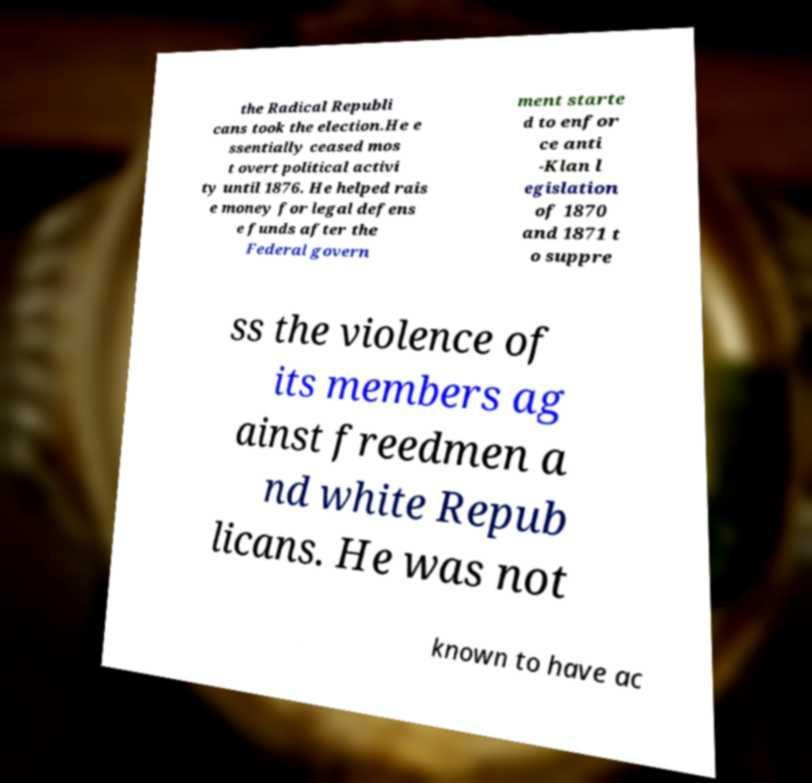For documentation purposes, I need the text within this image transcribed. Could you provide that? the Radical Republi cans took the election.He e ssentially ceased mos t overt political activi ty until 1876. He helped rais e money for legal defens e funds after the Federal govern ment starte d to enfor ce anti -Klan l egislation of 1870 and 1871 t o suppre ss the violence of its members ag ainst freedmen a nd white Repub licans. He was not known to have ac 